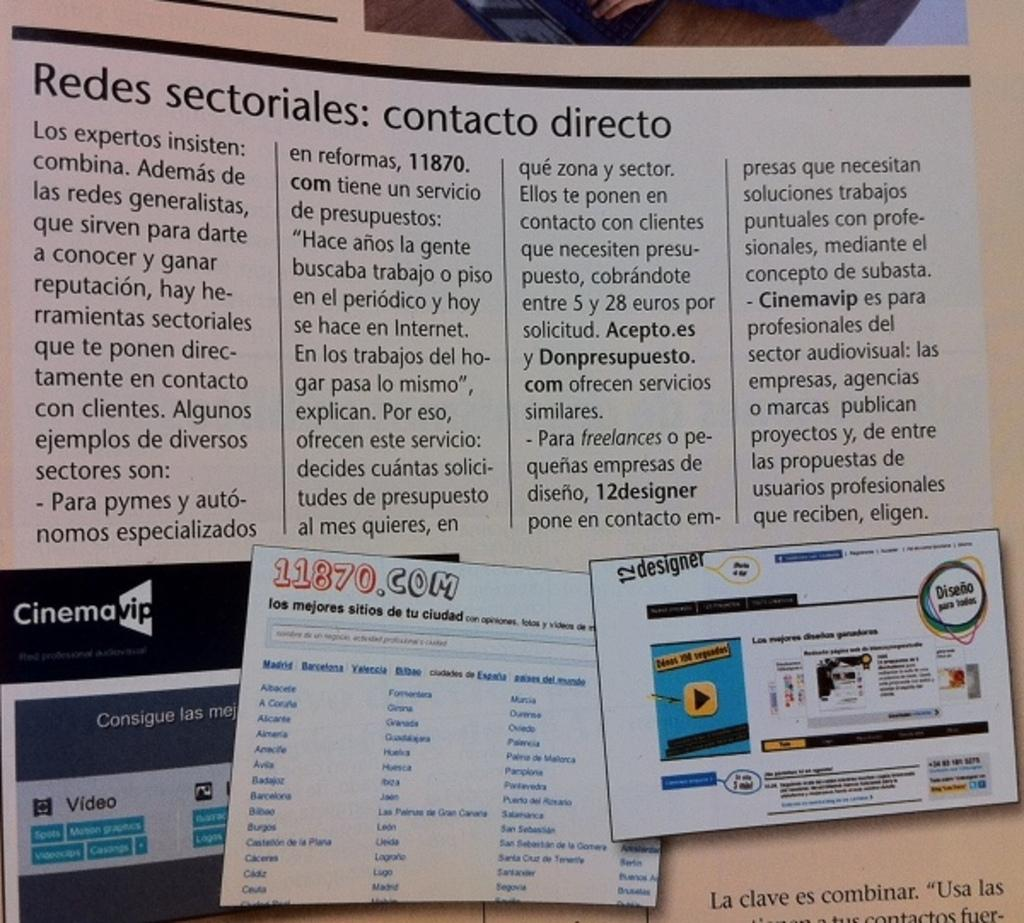<image>
Relay a brief, clear account of the picture shown. The bottom of the poster has an ad for CinemaVIP in black 